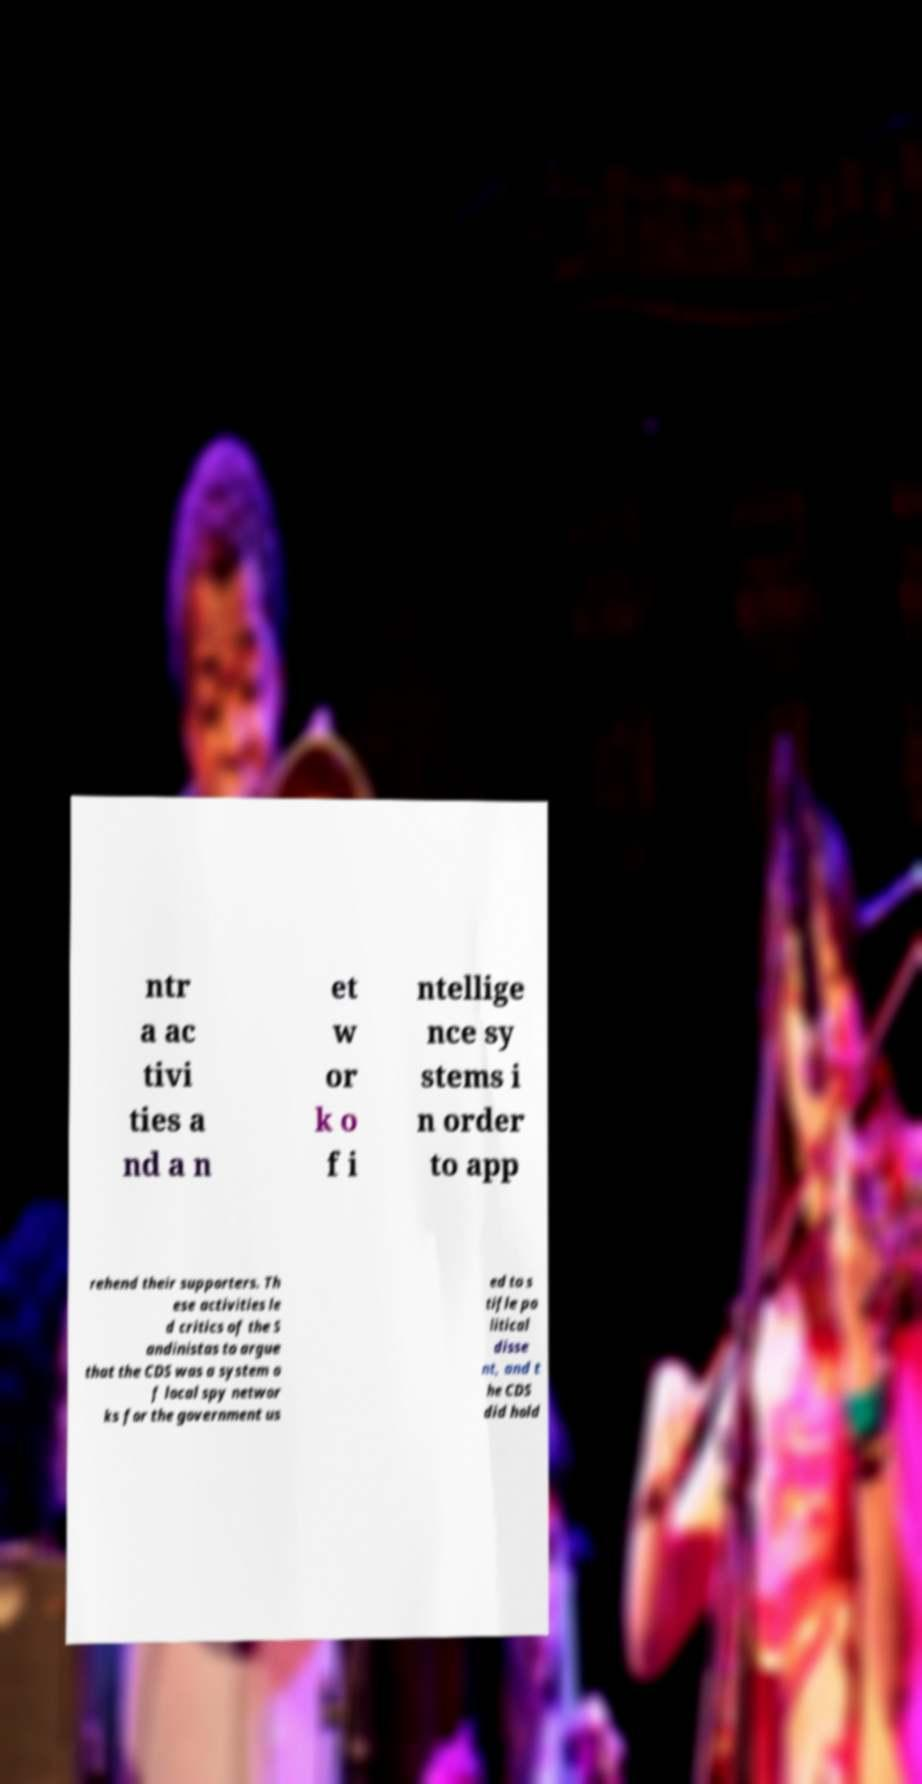Can you read and provide the text displayed in the image?This photo seems to have some interesting text. Can you extract and type it out for me? ntr a ac tivi ties a nd a n et w or k o f i ntellige nce sy stems i n order to app rehend their supporters. Th ese activities le d critics of the S andinistas to argue that the CDS was a system o f local spy networ ks for the government us ed to s tifle po litical disse nt, and t he CDS did hold 